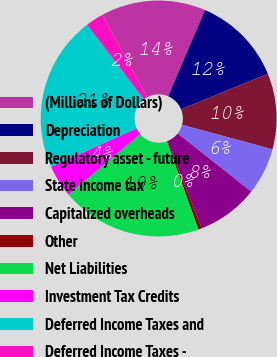Convert chart. <chart><loc_0><loc_0><loc_500><loc_500><pie_chart><fcel>(Millions of Dollars)<fcel>Depreciation<fcel>Regulatory asset - future<fcel>State income tax<fcel>Capitalized overheads<fcel>Other<fcel>Net Liabilities<fcel>Investment Tax Credits<fcel>Deferred Income Taxes and<fcel>Deferred Income Taxes -<nl><fcel>14.36%<fcel>12.38%<fcel>10.4%<fcel>6.43%<fcel>8.41%<fcel>0.47%<fcel>19.33%<fcel>4.44%<fcel>21.32%<fcel>2.46%<nl></chart> 